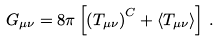Convert formula to latex. <formula><loc_0><loc_0><loc_500><loc_500>G _ { \mu \nu } = 8 \pi \left [ \left ( T _ { \mu \nu } \right ) ^ { C } + \langle T _ { \mu \nu } \rangle \right ] \, .</formula> 